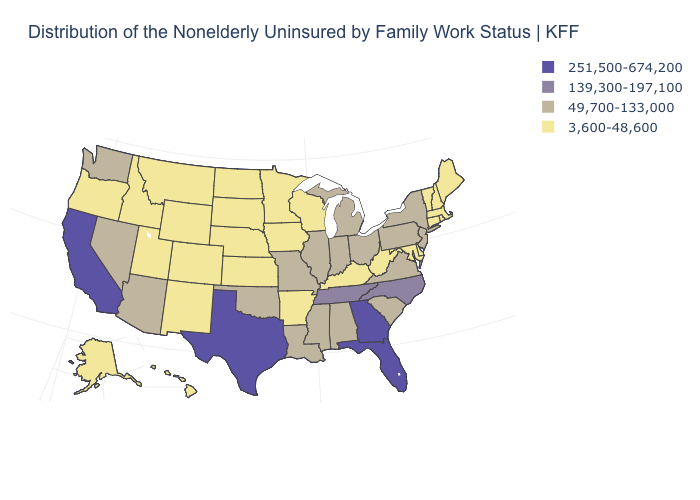Among the states that border Georgia , does Alabama have the highest value?
Keep it brief. No. What is the value of New Jersey?
Quick response, please. 49,700-133,000. Name the states that have a value in the range 251,500-674,200?
Write a very short answer. California, Florida, Georgia, Texas. Among the states that border South Carolina , which have the highest value?
Be succinct. Georgia. Does Mississippi have a lower value than North Carolina?
Be succinct. Yes. Which states have the lowest value in the USA?
Keep it brief. Alaska, Arkansas, Colorado, Connecticut, Delaware, Hawaii, Idaho, Iowa, Kansas, Kentucky, Maine, Maryland, Massachusetts, Minnesota, Montana, Nebraska, New Hampshire, New Mexico, North Dakota, Oregon, Rhode Island, South Dakota, Utah, Vermont, West Virginia, Wisconsin, Wyoming. Does Massachusetts have a lower value than Pennsylvania?
Write a very short answer. Yes. Among the states that border Oklahoma , which have the highest value?
Concise answer only. Texas. What is the value of Tennessee?
Keep it brief. 139,300-197,100. Name the states that have a value in the range 49,700-133,000?
Be succinct. Alabama, Arizona, Illinois, Indiana, Louisiana, Michigan, Mississippi, Missouri, Nevada, New Jersey, New York, Ohio, Oklahoma, Pennsylvania, South Carolina, Virginia, Washington. What is the value of Utah?
Answer briefly. 3,600-48,600. Which states hav the highest value in the West?
Be succinct. California. What is the highest value in the USA?
Concise answer only. 251,500-674,200. What is the lowest value in states that border Minnesota?
Answer briefly. 3,600-48,600. Does Missouri have the lowest value in the MidWest?
Write a very short answer. No. 